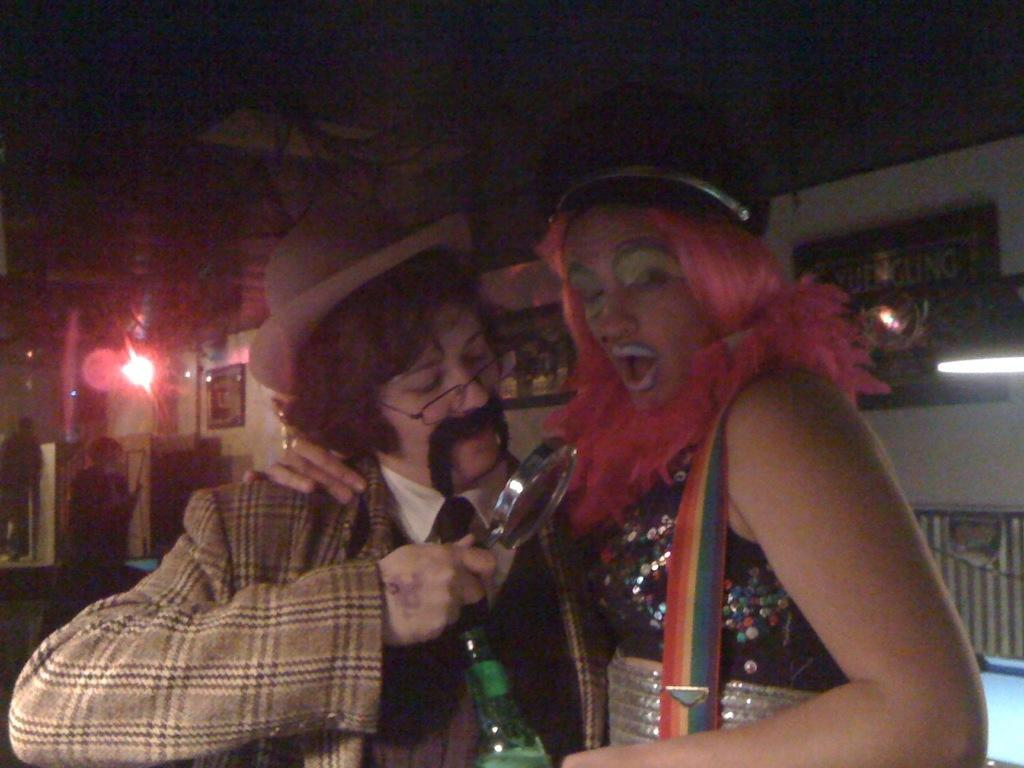How many people are present in the image? There are two people in the image. What is one person doing with their hands? One person is holding an object, which appears to be a bottle. What can be seen in the background of the image? There are people, a wall, lights, and some unspecified objects visible in the background of the image. What type of zinc is being used to rub on the wall in the image? There is no zinc or rubbing action present in the image. Are the people in the background talking to each other in the image? The conversation does not mention any talking or communication between the people in the background, so we cannot definitively answer this question based on the provided facts. 